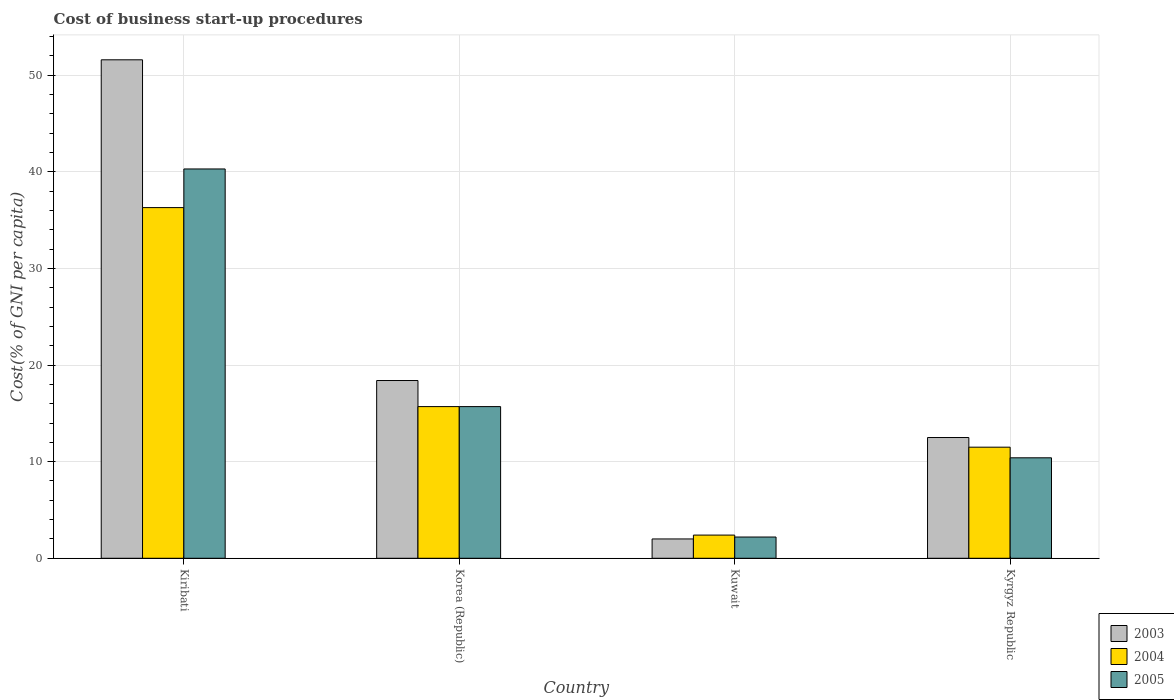How many groups of bars are there?
Keep it short and to the point. 4. Are the number of bars per tick equal to the number of legend labels?
Your response must be concise. Yes. How many bars are there on the 2nd tick from the right?
Offer a terse response. 3. What is the label of the 2nd group of bars from the left?
Ensure brevity in your answer.  Korea (Republic). In how many cases, is the number of bars for a given country not equal to the number of legend labels?
Give a very brief answer. 0. What is the cost of business start-up procedures in 2004 in Kiribati?
Provide a succinct answer. 36.3. Across all countries, what is the maximum cost of business start-up procedures in 2004?
Give a very brief answer. 36.3. Across all countries, what is the minimum cost of business start-up procedures in 2005?
Give a very brief answer. 2.2. In which country was the cost of business start-up procedures in 2004 maximum?
Provide a short and direct response. Kiribati. In which country was the cost of business start-up procedures in 2003 minimum?
Make the answer very short. Kuwait. What is the total cost of business start-up procedures in 2005 in the graph?
Provide a short and direct response. 68.6. What is the difference between the cost of business start-up procedures in 2003 in Kuwait and that in Kyrgyz Republic?
Keep it short and to the point. -10.5. What is the difference between the cost of business start-up procedures in 2005 in Kyrgyz Republic and the cost of business start-up procedures in 2003 in Korea (Republic)?
Ensure brevity in your answer.  -8. What is the average cost of business start-up procedures in 2005 per country?
Provide a succinct answer. 17.15. What is the difference between the cost of business start-up procedures of/in 2004 and cost of business start-up procedures of/in 2003 in Kyrgyz Republic?
Provide a short and direct response. -1. In how many countries, is the cost of business start-up procedures in 2003 greater than 18 %?
Offer a very short reply. 2. What is the ratio of the cost of business start-up procedures in 2004 in Korea (Republic) to that in Kuwait?
Provide a short and direct response. 6.54. Is the cost of business start-up procedures in 2004 in Korea (Republic) less than that in Kuwait?
Keep it short and to the point. No. Is the difference between the cost of business start-up procedures in 2004 in Kiribati and Kyrgyz Republic greater than the difference between the cost of business start-up procedures in 2003 in Kiribati and Kyrgyz Republic?
Provide a succinct answer. No. What is the difference between the highest and the second highest cost of business start-up procedures in 2003?
Ensure brevity in your answer.  -33.2. What is the difference between the highest and the lowest cost of business start-up procedures in 2005?
Your answer should be compact. 38.1. Is the sum of the cost of business start-up procedures in 2005 in Kiribati and Kuwait greater than the maximum cost of business start-up procedures in 2003 across all countries?
Provide a succinct answer. No. What does the 3rd bar from the left in Kyrgyz Republic represents?
Ensure brevity in your answer.  2005. Is it the case that in every country, the sum of the cost of business start-up procedures in 2005 and cost of business start-up procedures in 2003 is greater than the cost of business start-up procedures in 2004?
Make the answer very short. Yes. How many bars are there?
Make the answer very short. 12. How many countries are there in the graph?
Offer a very short reply. 4. What is the difference between two consecutive major ticks on the Y-axis?
Provide a short and direct response. 10. Are the values on the major ticks of Y-axis written in scientific E-notation?
Offer a very short reply. No. Does the graph contain any zero values?
Provide a succinct answer. No. Does the graph contain grids?
Offer a very short reply. Yes. How many legend labels are there?
Ensure brevity in your answer.  3. How are the legend labels stacked?
Provide a succinct answer. Vertical. What is the title of the graph?
Keep it short and to the point. Cost of business start-up procedures. Does "1990" appear as one of the legend labels in the graph?
Keep it short and to the point. No. What is the label or title of the X-axis?
Your response must be concise. Country. What is the label or title of the Y-axis?
Offer a very short reply. Cost(% of GNI per capita). What is the Cost(% of GNI per capita) of 2003 in Kiribati?
Ensure brevity in your answer.  51.6. What is the Cost(% of GNI per capita) in 2004 in Kiribati?
Ensure brevity in your answer.  36.3. What is the Cost(% of GNI per capita) of 2005 in Kiribati?
Provide a succinct answer. 40.3. What is the Cost(% of GNI per capita) of 2004 in Korea (Republic)?
Your response must be concise. 15.7. What is the Cost(% of GNI per capita) of 2005 in Korea (Republic)?
Give a very brief answer. 15.7. What is the Cost(% of GNI per capita) of 2003 in Kuwait?
Make the answer very short. 2. What is the Cost(% of GNI per capita) in 2005 in Kuwait?
Ensure brevity in your answer.  2.2. What is the Cost(% of GNI per capita) of 2003 in Kyrgyz Republic?
Your answer should be compact. 12.5. Across all countries, what is the maximum Cost(% of GNI per capita) in 2003?
Make the answer very short. 51.6. Across all countries, what is the maximum Cost(% of GNI per capita) of 2004?
Provide a succinct answer. 36.3. Across all countries, what is the maximum Cost(% of GNI per capita) of 2005?
Provide a short and direct response. 40.3. What is the total Cost(% of GNI per capita) of 2003 in the graph?
Provide a short and direct response. 84.5. What is the total Cost(% of GNI per capita) in 2004 in the graph?
Your answer should be very brief. 65.9. What is the total Cost(% of GNI per capita) of 2005 in the graph?
Keep it short and to the point. 68.6. What is the difference between the Cost(% of GNI per capita) in 2003 in Kiribati and that in Korea (Republic)?
Ensure brevity in your answer.  33.2. What is the difference between the Cost(% of GNI per capita) in 2004 in Kiribati and that in Korea (Republic)?
Provide a short and direct response. 20.6. What is the difference between the Cost(% of GNI per capita) of 2005 in Kiribati and that in Korea (Republic)?
Ensure brevity in your answer.  24.6. What is the difference between the Cost(% of GNI per capita) in 2003 in Kiribati and that in Kuwait?
Your answer should be compact. 49.6. What is the difference between the Cost(% of GNI per capita) in 2004 in Kiribati and that in Kuwait?
Provide a succinct answer. 33.9. What is the difference between the Cost(% of GNI per capita) in 2005 in Kiribati and that in Kuwait?
Ensure brevity in your answer.  38.1. What is the difference between the Cost(% of GNI per capita) of 2003 in Kiribati and that in Kyrgyz Republic?
Ensure brevity in your answer.  39.1. What is the difference between the Cost(% of GNI per capita) of 2004 in Kiribati and that in Kyrgyz Republic?
Offer a very short reply. 24.8. What is the difference between the Cost(% of GNI per capita) in 2005 in Kiribati and that in Kyrgyz Republic?
Keep it short and to the point. 29.9. What is the difference between the Cost(% of GNI per capita) in 2003 in Korea (Republic) and that in Kuwait?
Offer a very short reply. 16.4. What is the difference between the Cost(% of GNI per capita) in 2004 in Korea (Republic) and that in Kuwait?
Your response must be concise. 13.3. What is the difference between the Cost(% of GNI per capita) in 2004 in Korea (Republic) and that in Kyrgyz Republic?
Make the answer very short. 4.2. What is the difference between the Cost(% of GNI per capita) in 2005 in Korea (Republic) and that in Kyrgyz Republic?
Your answer should be very brief. 5.3. What is the difference between the Cost(% of GNI per capita) in 2003 in Kuwait and that in Kyrgyz Republic?
Ensure brevity in your answer.  -10.5. What is the difference between the Cost(% of GNI per capita) of 2005 in Kuwait and that in Kyrgyz Republic?
Offer a very short reply. -8.2. What is the difference between the Cost(% of GNI per capita) in 2003 in Kiribati and the Cost(% of GNI per capita) in 2004 in Korea (Republic)?
Your response must be concise. 35.9. What is the difference between the Cost(% of GNI per capita) of 2003 in Kiribati and the Cost(% of GNI per capita) of 2005 in Korea (Republic)?
Offer a very short reply. 35.9. What is the difference between the Cost(% of GNI per capita) in 2004 in Kiribati and the Cost(% of GNI per capita) in 2005 in Korea (Republic)?
Provide a succinct answer. 20.6. What is the difference between the Cost(% of GNI per capita) of 2003 in Kiribati and the Cost(% of GNI per capita) of 2004 in Kuwait?
Your answer should be very brief. 49.2. What is the difference between the Cost(% of GNI per capita) of 2003 in Kiribati and the Cost(% of GNI per capita) of 2005 in Kuwait?
Make the answer very short. 49.4. What is the difference between the Cost(% of GNI per capita) in 2004 in Kiribati and the Cost(% of GNI per capita) in 2005 in Kuwait?
Your response must be concise. 34.1. What is the difference between the Cost(% of GNI per capita) of 2003 in Kiribati and the Cost(% of GNI per capita) of 2004 in Kyrgyz Republic?
Your answer should be compact. 40.1. What is the difference between the Cost(% of GNI per capita) in 2003 in Kiribati and the Cost(% of GNI per capita) in 2005 in Kyrgyz Republic?
Ensure brevity in your answer.  41.2. What is the difference between the Cost(% of GNI per capita) in 2004 in Kiribati and the Cost(% of GNI per capita) in 2005 in Kyrgyz Republic?
Ensure brevity in your answer.  25.9. What is the difference between the Cost(% of GNI per capita) of 2004 in Korea (Republic) and the Cost(% of GNI per capita) of 2005 in Kuwait?
Give a very brief answer. 13.5. What is the difference between the Cost(% of GNI per capita) in 2003 in Korea (Republic) and the Cost(% of GNI per capita) in 2004 in Kyrgyz Republic?
Your answer should be compact. 6.9. What is the average Cost(% of GNI per capita) of 2003 per country?
Your answer should be very brief. 21.12. What is the average Cost(% of GNI per capita) of 2004 per country?
Keep it short and to the point. 16.48. What is the average Cost(% of GNI per capita) in 2005 per country?
Offer a very short reply. 17.15. What is the difference between the Cost(% of GNI per capita) in 2003 and Cost(% of GNI per capita) in 2004 in Korea (Republic)?
Offer a terse response. 2.7. What is the difference between the Cost(% of GNI per capita) in 2003 and Cost(% of GNI per capita) in 2005 in Korea (Republic)?
Provide a short and direct response. 2.7. What is the difference between the Cost(% of GNI per capita) in 2004 and Cost(% of GNI per capita) in 2005 in Kuwait?
Offer a very short reply. 0.2. What is the difference between the Cost(% of GNI per capita) in 2003 and Cost(% of GNI per capita) in 2005 in Kyrgyz Republic?
Give a very brief answer. 2.1. What is the difference between the Cost(% of GNI per capita) of 2004 and Cost(% of GNI per capita) of 2005 in Kyrgyz Republic?
Ensure brevity in your answer.  1.1. What is the ratio of the Cost(% of GNI per capita) of 2003 in Kiribati to that in Korea (Republic)?
Provide a short and direct response. 2.8. What is the ratio of the Cost(% of GNI per capita) in 2004 in Kiribati to that in Korea (Republic)?
Your answer should be compact. 2.31. What is the ratio of the Cost(% of GNI per capita) in 2005 in Kiribati to that in Korea (Republic)?
Give a very brief answer. 2.57. What is the ratio of the Cost(% of GNI per capita) of 2003 in Kiribati to that in Kuwait?
Your answer should be very brief. 25.8. What is the ratio of the Cost(% of GNI per capita) of 2004 in Kiribati to that in Kuwait?
Provide a succinct answer. 15.12. What is the ratio of the Cost(% of GNI per capita) of 2005 in Kiribati to that in Kuwait?
Make the answer very short. 18.32. What is the ratio of the Cost(% of GNI per capita) of 2003 in Kiribati to that in Kyrgyz Republic?
Keep it short and to the point. 4.13. What is the ratio of the Cost(% of GNI per capita) of 2004 in Kiribati to that in Kyrgyz Republic?
Keep it short and to the point. 3.16. What is the ratio of the Cost(% of GNI per capita) in 2005 in Kiribati to that in Kyrgyz Republic?
Give a very brief answer. 3.88. What is the ratio of the Cost(% of GNI per capita) in 2003 in Korea (Republic) to that in Kuwait?
Provide a succinct answer. 9.2. What is the ratio of the Cost(% of GNI per capita) in 2004 in Korea (Republic) to that in Kuwait?
Ensure brevity in your answer.  6.54. What is the ratio of the Cost(% of GNI per capita) of 2005 in Korea (Republic) to that in Kuwait?
Ensure brevity in your answer.  7.14. What is the ratio of the Cost(% of GNI per capita) of 2003 in Korea (Republic) to that in Kyrgyz Republic?
Ensure brevity in your answer.  1.47. What is the ratio of the Cost(% of GNI per capita) in 2004 in Korea (Republic) to that in Kyrgyz Republic?
Keep it short and to the point. 1.37. What is the ratio of the Cost(% of GNI per capita) of 2005 in Korea (Republic) to that in Kyrgyz Republic?
Your answer should be compact. 1.51. What is the ratio of the Cost(% of GNI per capita) of 2003 in Kuwait to that in Kyrgyz Republic?
Your answer should be compact. 0.16. What is the ratio of the Cost(% of GNI per capita) of 2004 in Kuwait to that in Kyrgyz Republic?
Provide a short and direct response. 0.21. What is the ratio of the Cost(% of GNI per capita) of 2005 in Kuwait to that in Kyrgyz Republic?
Ensure brevity in your answer.  0.21. What is the difference between the highest and the second highest Cost(% of GNI per capita) in 2003?
Provide a succinct answer. 33.2. What is the difference between the highest and the second highest Cost(% of GNI per capita) of 2004?
Offer a very short reply. 20.6. What is the difference between the highest and the second highest Cost(% of GNI per capita) in 2005?
Ensure brevity in your answer.  24.6. What is the difference between the highest and the lowest Cost(% of GNI per capita) in 2003?
Keep it short and to the point. 49.6. What is the difference between the highest and the lowest Cost(% of GNI per capita) of 2004?
Make the answer very short. 33.9. What is the difference between the highest and the lowest Cost(% of GNI per capita) of 2005?
Your answer should be very brief. 38.1. 